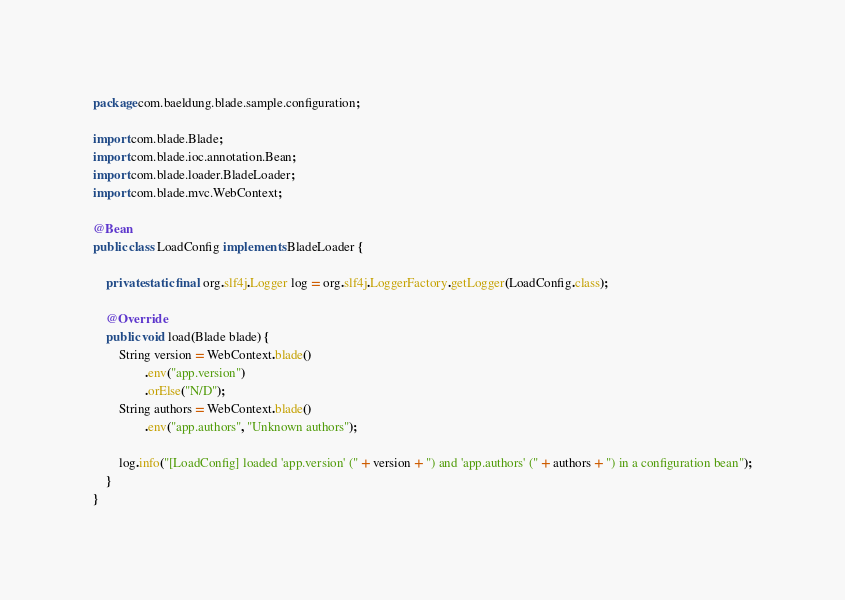Convert code to text. <code><loc_0><loc_0><loc_500><loc_500><_Java_>package com.baeldung.blade.sample.configuration;

import com.blade.Blade;
import com.blade.ioc.annotation.Bean;
import com.blade.loader.BladeLoader;
import com.blade.mvc.WebContext;

@Bean
public class LoadConfig implements BladeLoader {

    private static final org.slf4j.Logger log = org.slf4j.LoggerFactory.getLogger(LoadConfig.class);

    @Override
    public void load(Blade blade) {
        String version = WebContext.blade()
                .env("app.version")
                .orElse("N/D");
        String authors = WebContext.blade()
                .env("app.authors", "Unknown authors");

        log.info("[LoadConfig] loaded 'app.version' (" + version + ") and 'app.authors' (" + authors + ") in a configuration bean");
    }
}</code> 